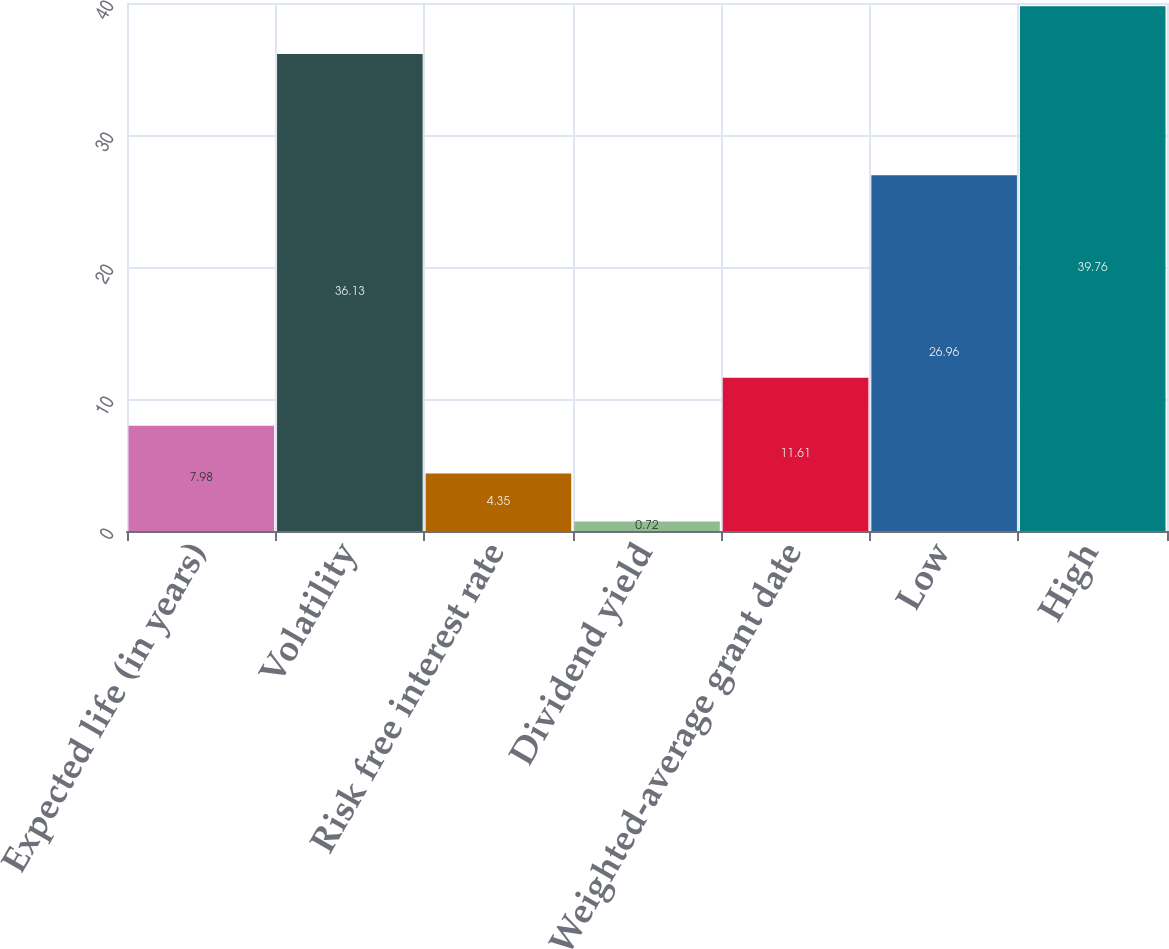Convert chart. <chart><loc_0><loc_0><loc_500><loc_500><bar_chart><fcel>Expected life (in years)<fcel>Volatility<fcel>Risk free interest rate<fcel>Dividend yield<fcel>Weighted-average grant date<fcel>Low<fcel>High<nl><fcel>7.98<fcel>36.13<fcel>4.35<fcel>0.72<fcel>11.61<fcel>26.96<fcel>39.76<nl></chart> 